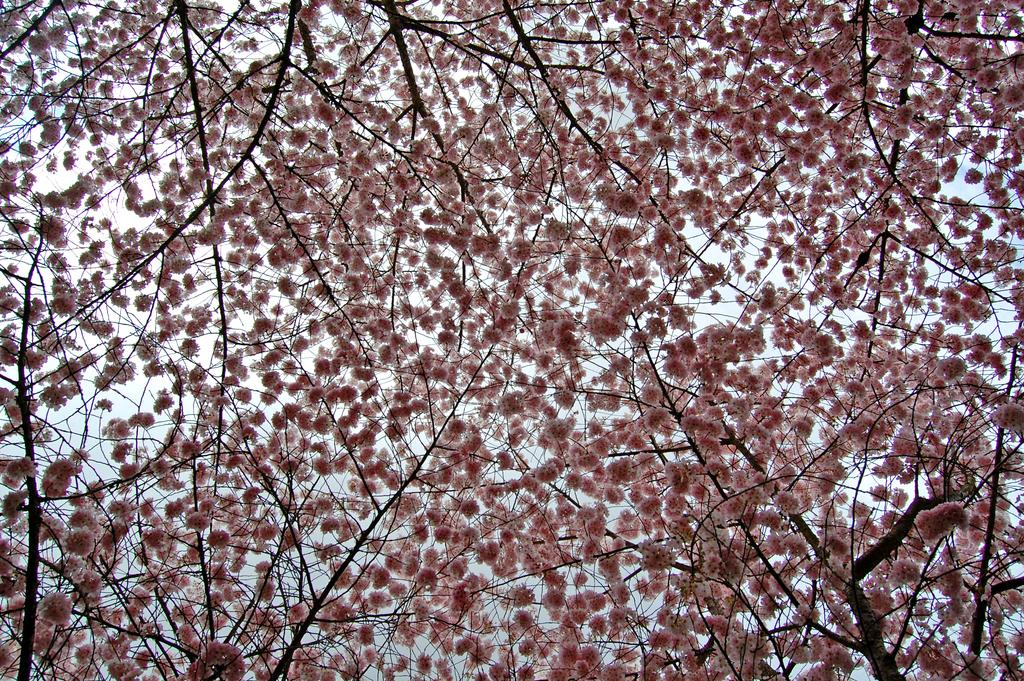What type of vegetation can be seen in the image? There are branches with flowers in the image. What can be seen in the background of the image? There is sky visible in the background of the image. Who is the creator of the art in the image? The image does not depict any art or artist, so it is not possible to determine the creator. 